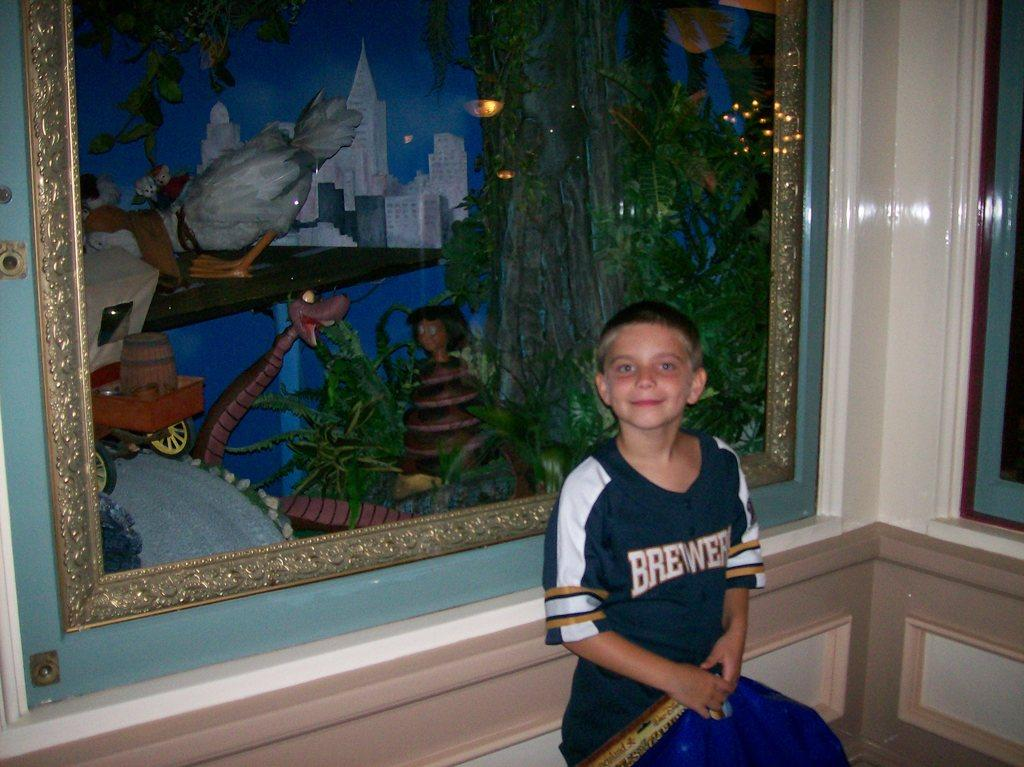<image>
Describe the image concisely. A young boy stands in front of a painting wearing a Brewers jersey 